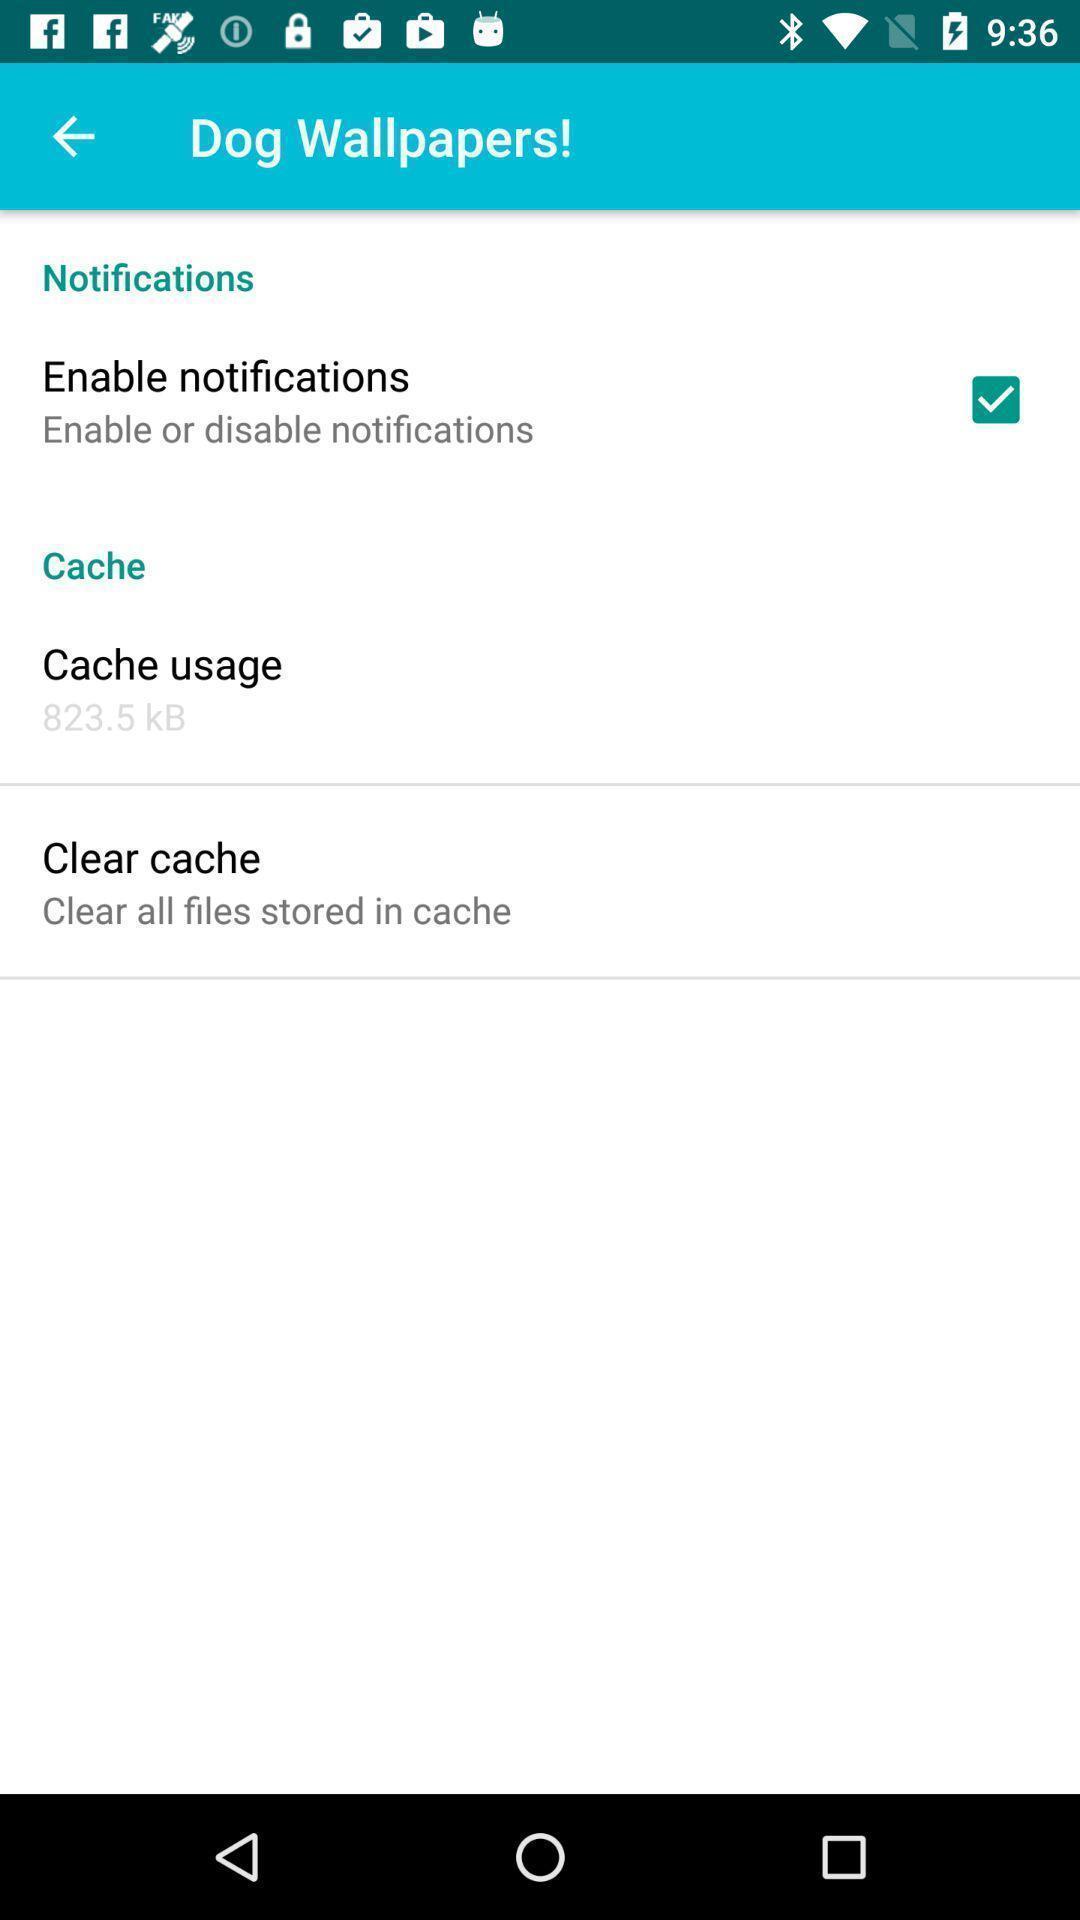Provide a detailed account of this screenshot. Page displayed notifications and cache settings. 